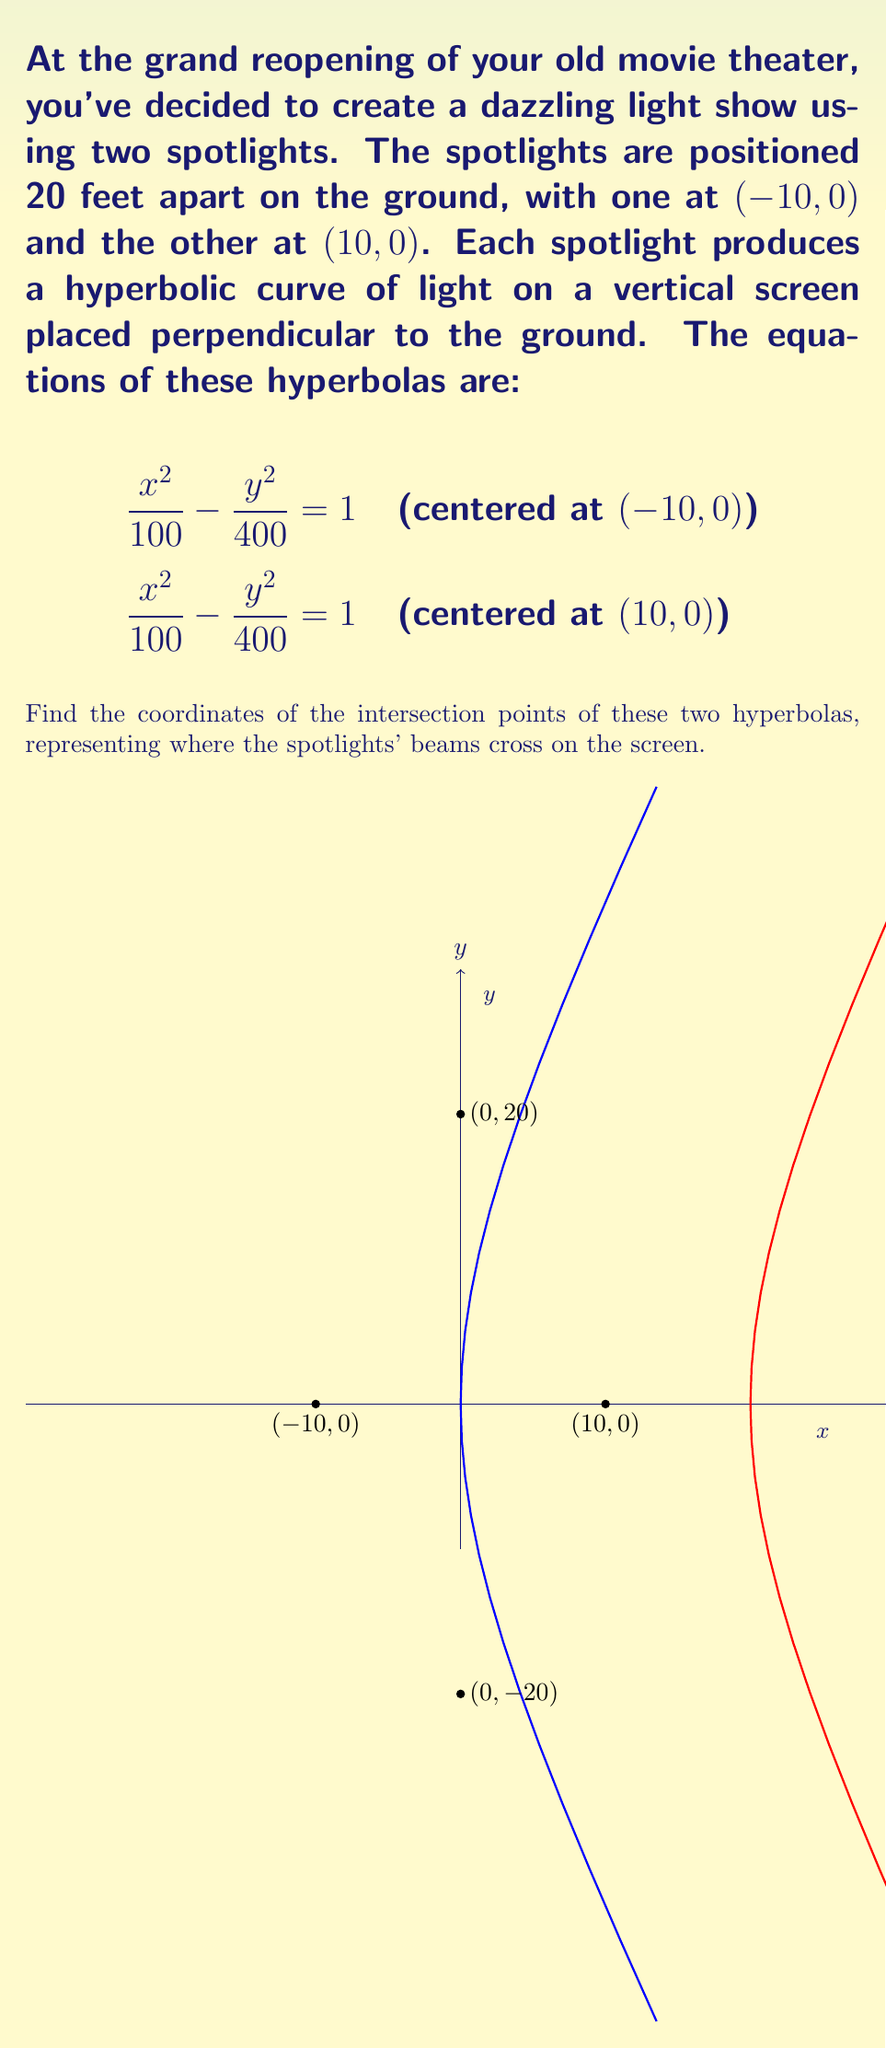Teach me how to tackle this problem. Let's approach this step-by-step:

1) First, we need to write the equations of both hyperbolas in standard form. 
   For the left spotlight: $\frac{(x+10)^2}{100} - \frac{y^2}{400} = 1$
   For the right spotlight: $\frac{(x-10)^2}{100} - \frac{y^2}{400} = 1$

2) At the intersection points, both equations will be true. So we can set them equal to each other:

   $\frac{(x+10)^2}{100} - \frac{y^2}{400} = \frac{(x-10)^2}{100} - \frac{y^2}{400}$

3) The $\frac{y^2}{400}$ terms cancel out on both sides:

   $\frac{(x+10)^2}{100} = \frac{(x-10)^2}{100}$

4) Multiply both sides by 100:

   $(x+10)^2 = (x-10)^2$

5) Expand the squares:

   $x^2 + 20x + 100 = x^2 - 20x + 100$

6) The $x^2$ and 100 terms cancel out:

   $20x = -20x$

7) Add $20x$ to both sides:

   $40x = 0$

8) Divide by 40:

   $x = 0$

9) So the x-coordinate of the intersection points is 0. To find the y-coordinates, we can substitute x=0 into either of the original equations. Let's use the first one:

   $\frac{(0+10)^2}{100} - \frac{y^2}{400} = 1$

10) Simplify:

    $1 - \frac{y^2}{400} = 1$

11) Subtract 1 from both sides:

    $-\frac{y^2}{400} = 0$

12) Multiply both sides by -400:

    $y^2 = 400$

13) Take the square root of both sides:

    $y = \pm 20$

Therefore, the intersection points are (0, 20) and (0, -20).
Answer: (0, 20) and (0, -20) 